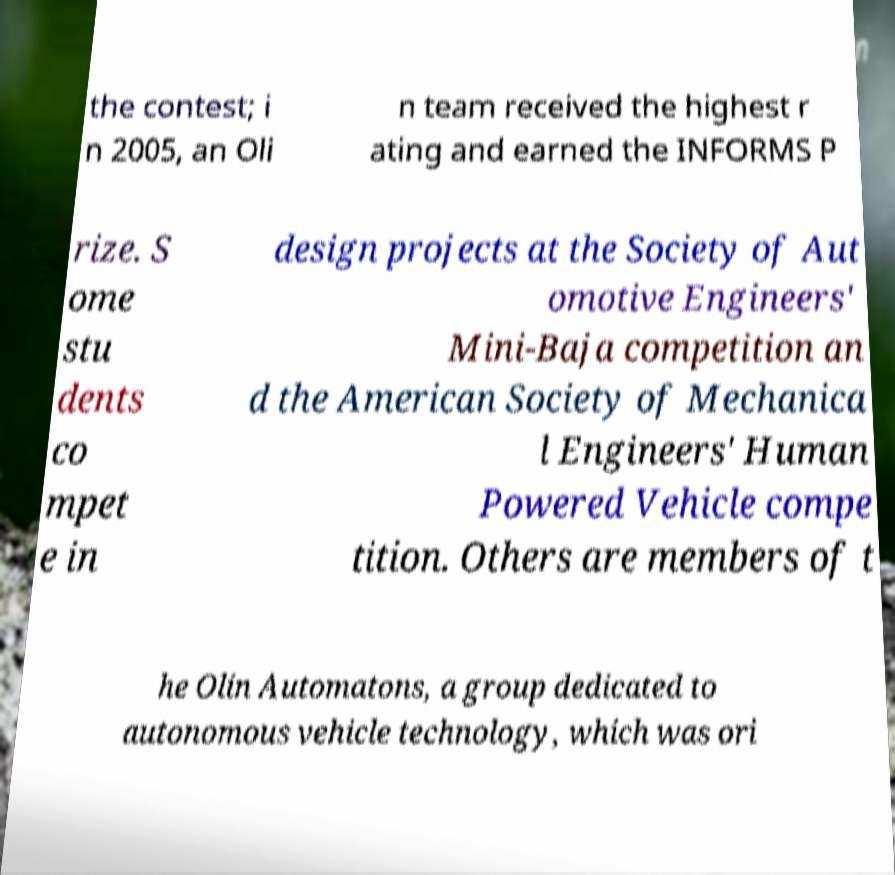Could you assist in decoding the text presented in this image and type it out clearly? the contest; i n 2005, an Oli n team received the highest r ating and earned the INFORMS P rize. S ome stu dents co mpet e in design projects at the Society of Aut omotive Engineers' Mini-Baja competition an d the American Society of Mechanica l Engineers' Human Powered Vehicle compe tition. Others are members of t he Olin Automatons, a group dedicated to autonomous vehicle technology, which was ori 